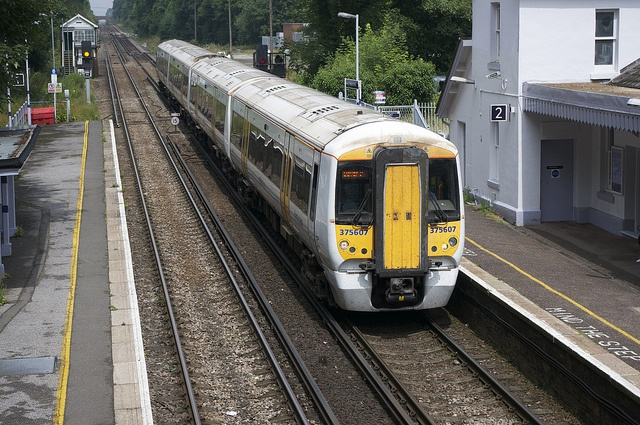Describe the objects in this image and their specific colors. I can see train in black, gray, lightgray, and darkgray tones, traffic light in black, gray, and purple tones, and traffic light in black, maroon, and gray tones in this image. 